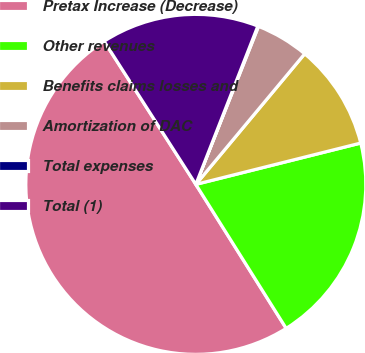<chart> <loc_0><loc_0><loc_500><loc_500><pie_chart><fcel>Pretax Increase (Decrease)<fcel>Other revenues<fcel>Benefits claims losses and<fcel>Amortization of DAC<fcel>Total expenses<fcel>Total (1)<nl><fcel>49.85%<fcel>19.99%<fcel>10.03%<fcel>5.05%<fcel>0.07%<fcel>15.01%<nl></chart> 